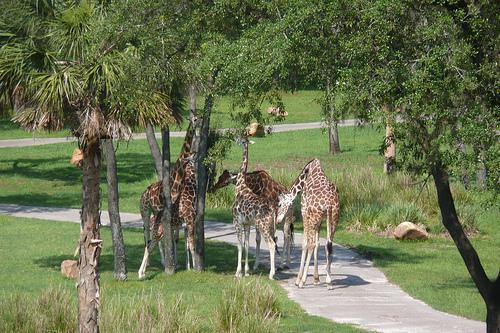How many giraffes?
Give a very brief answer. 4. How many giraffes are pictured?
Give a very brief answer. 5. How many legs do the giraffe have?
Give a very brief answer. 4. 